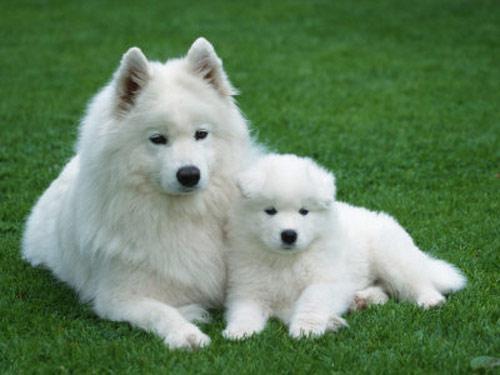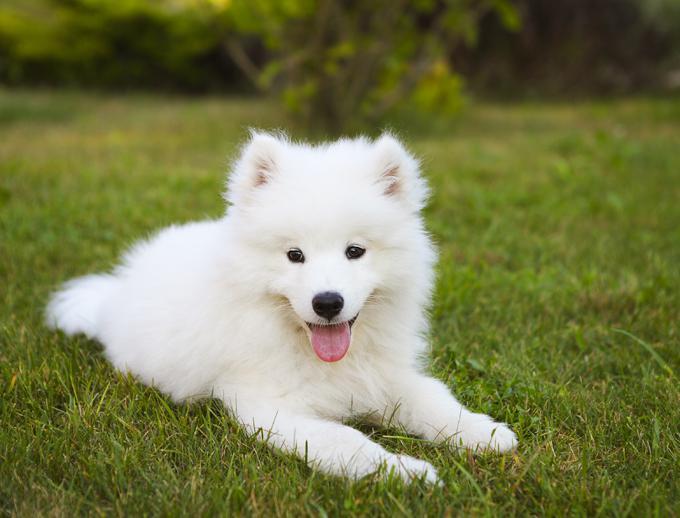The first image is the image on the left, the second image is the image on the right. For the images shown, is this caption "The dog on the right has its tongue sticking out." true? Answer yes or no. Yes. 